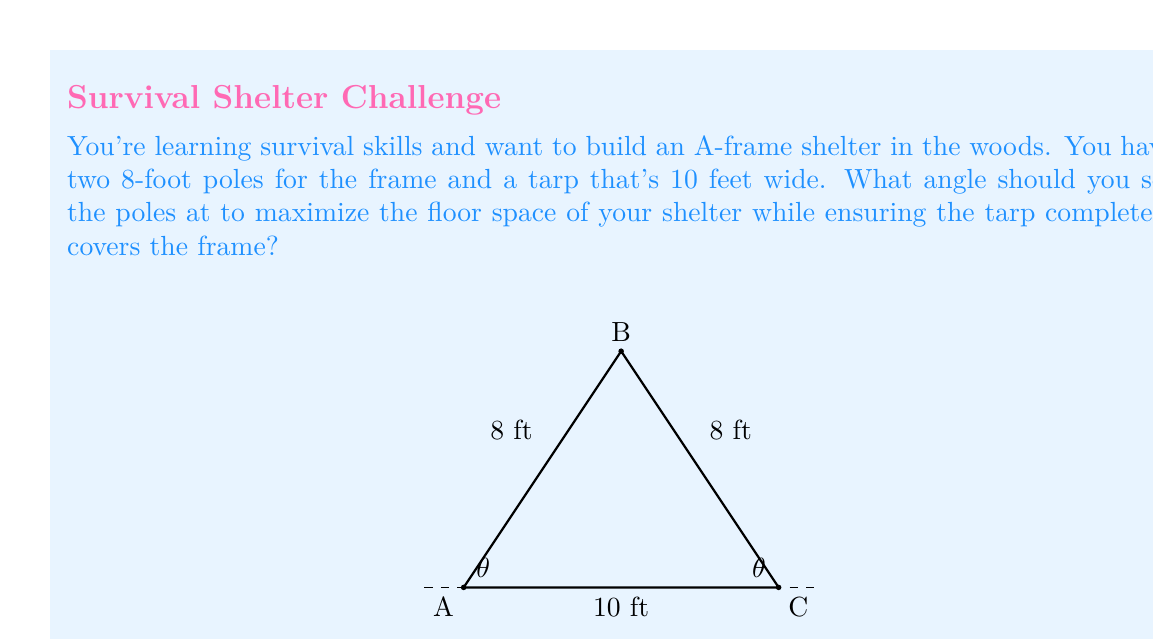Solve this math problem. Let's approach this step-by-step:

1) First, we need to understand that the A-frame shelter forms an isosceles triangle, where the two 8-foot poles are the equal sides.

2) The width of the tarp (10 feet) will be the base of this triangle.

3) We want to maximize the floor space, which is equivalent to maximizing the base of the triangle.

4) Let's define $\theta$ as the angle between each pole and the ground.

5) Using trigonometry, we can express the base of the triangle (b) in terms of $\theta$:

   $$b = 2 \cdot 8 \cdot \cos\theta = 16\cos\theta$$

6) We know that b must equal 10 (the width of the tarp):

   $$16\cos\theta = 10$$

7) Solving for $\theta$:

   $$\cos\theta = \frac{10}{16} = \frac{5}{8}$$
   $$\theta = \arccos(\frac{5}{8})$$

8) Using a calculator or trigonometric tables:

   $$\theta \approx 51.32^\circ$$

9) To verify, let's calculate the height of the triangle:

   $$h = 8 \cdot \sin(51.32^\circ) \approx 6.25 \text{ feet}$$

10) And the diagonal length (which should equal 8):

    $$\sqrt{5^2 + 6.25^2} \approx 8 \text{ feet}$$

This confirms our calculation is correct.
Answer: The optimal angle to set the poles is approximately $51.32^\circ$ from the ground. 